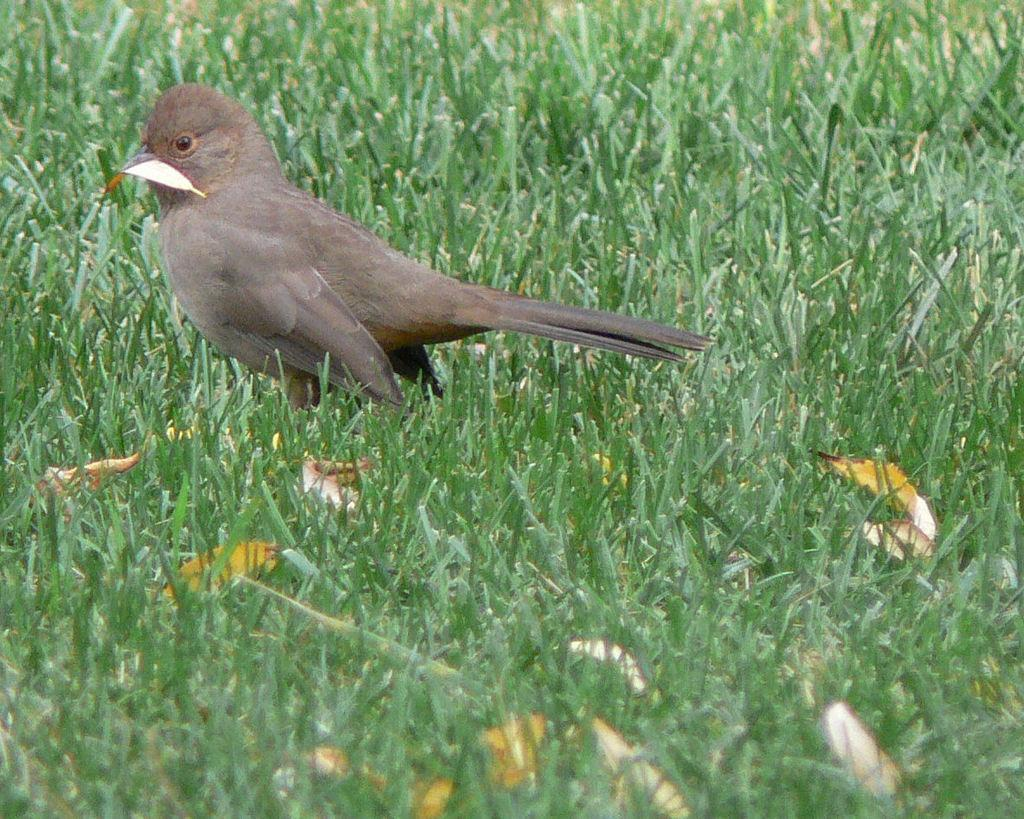What type of animal can be seen in the picture? There is a bird in the picture. What type of vegetation is present in the picture? There is grass and leaves in the picture. Can you describe the interaction between the bird and the leaves? A leaf is on the bird. How many cats are sitting on the scale in the picture? There are no cats or scales present in the picture. 